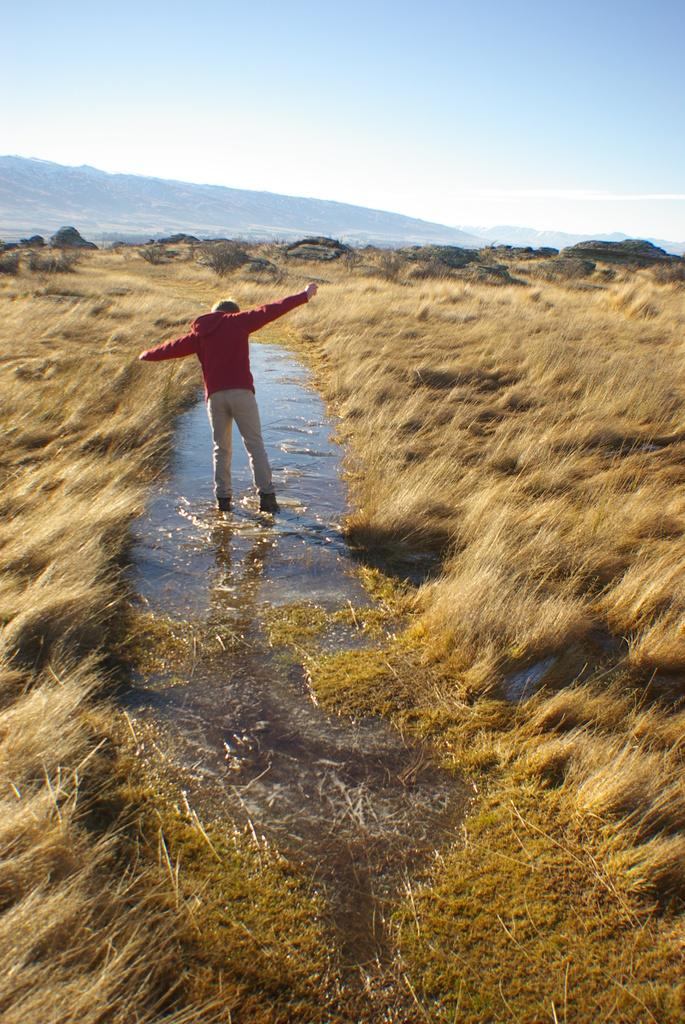What is the person in the image doing? The person is standing in the water. What type of vegetation can be seen in the image? There is grass visible in the image. What type of landscape feature is present in the background of the image? There are mountains in the image. What is visible at the top of the image? The sky is visible at the top of the image. How many plants are growing in a straight line in the image? There are no plants growing in a straight line in the image. 